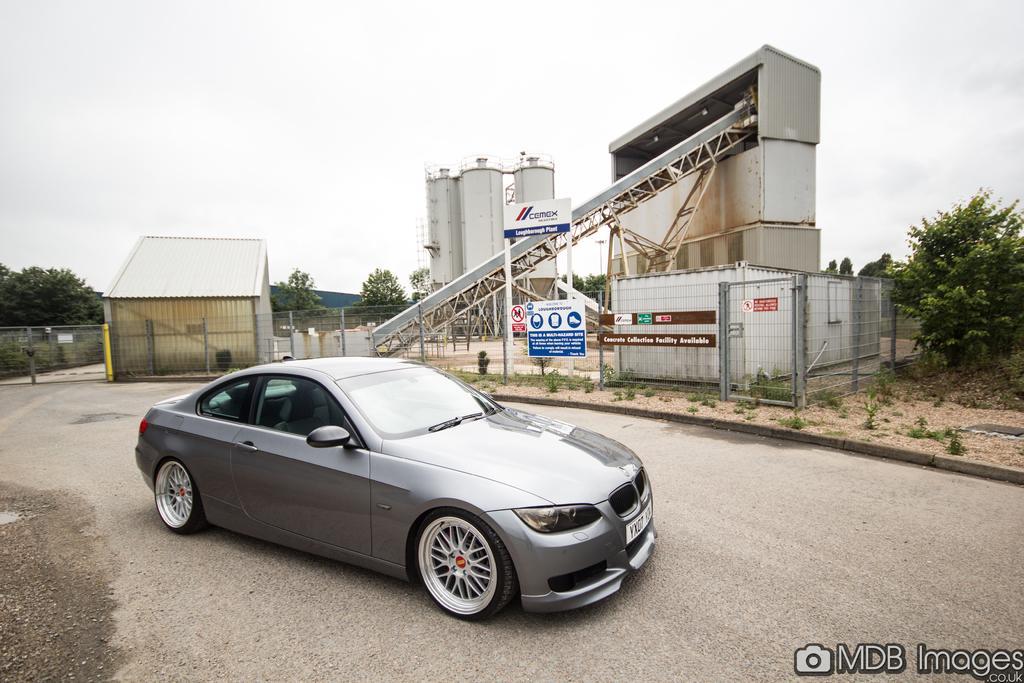Can you describe this image briefly? This is an outside view. Here I can see a car on the road. In the background there are some buildings. On the right and left sides of the image I can see some trees. At the top of the image I can see the sky. In the bottom right there is some edited text. 